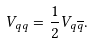Convert formula to latex. <formula><loc_0><loc_0><loc_500><loc_500>V _ { q q } = \frac { 1 } { 2 } V _ { q \overline { q } } .</formula> 